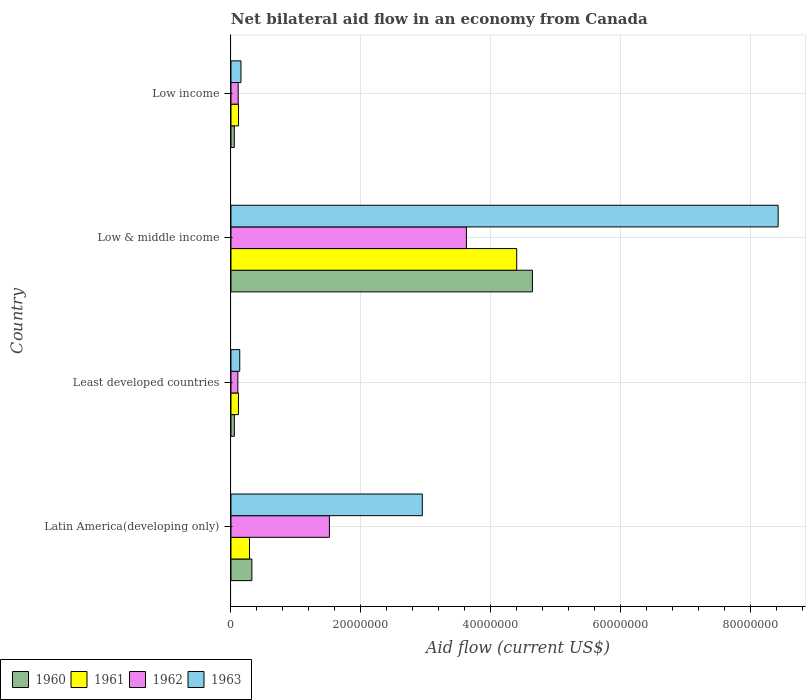How many different coloured bars are there?
Your answer should be very brief. 4. How many groups of bars are there?
Provide a succinct answer. 4. How many bars are there on the 1st tick from the top?
Give a very brief answer. 4. What is the label of the 2nd group of bars from the top?
Offer a terse response. Low & middle income. In how many cases, is the number of bars for a given country not equal to the number of legend labels?
Offer a terse response. 0. What is the net bilateral aid flow in 1962 in Latin America(developing only)?
Provide a succinct answer. 1.52e+07. Across all countries, what is the maximum net bilateral aid flow in 1963?
Give a very brief answer. 8.42e+07. Across all countries, what is the minimum net bilateral aid flow in 1962?
Offer a terse response. 1.06e+06. What is the total net bilateral aid flow in 1961 in the graph?
Offer a very short reply. 4.91e+07. What is the difference between the net bilateral aid flow in 1961 in Low & middle income and that in Low income?
Your response must be concise. 4.28e+07. What is the difference between the net bilateral aid flow in 1960 in Latin America(developing only) and the net bilateral aid flow in 1961 in Least developed countries?
Your answer should be compact. 2.07e+06. What is the average net bilateral aid flow in 1963 per country?
Provide a short and direct response. 2.91e+07. What is the difference between the net bilateral aid flow in 1960 and net bilateral aid flow in 1961 in Low & middle income?
Make the answer very short. 2.42e+06. What is the ratio of the net bilateral aid flow in 1960 in Least developed countries to that in Low & middle income?
Ensure brevity in your answer.  0.01. Is the difference between the net bilateral aid flow in 1960 in Latin America(developing only) and Low income greater than the difference between the net bilateral aid flow in 1961 in Latin America(developing only) and Low income?
Make the answer very short. Yes. What is the difference between the highest and the second highest net bilateral aid flow in 1961?
Give a very brief answer. 4.11e+07. What is the difference between the highest and the lowest net bilateral aid flow in 1960?
Keep it short and to the point. 4.59e+07. In how many countries, is the net bilateral aid flow in 1962 greater than the average net bilateral aid flow in 1962 taken over all countries?
Provide a succinct answer. 2. Is the sum of the net bilateral aid flow in 1962 in Least developed countries and Low income greater than the maximum net bilateral aid flow in 1961 across all countries?
Provide a short and direct response. No. Is it the case that in every country, the sum of the net bilateral aid flow in 1961 and net bilateral aid flow in 1963 is greater than the sum of net bilateral aid flow in 1962 and net bilateral aid flow in 1960?
Offer a terse response. No. What does the 2nd bar from the top in Latin America(developing only) represents?
Provide a short and direct response. 1962. Does the graph contain any zero values?
Keep it short and to the point. No. How are the legend labels stacked?
Make the answer very short. Horizontal. What is the title of the graph?
Provide a succinct answer. Net bilateral aid flow in an economy from Canada. Does "1998" appear as one of the legend labels in the graph?
Keep it short and to the point. No. What is the Aid flow (current US$) of 1960 in Latin America(developing only)?
Provide a succinct answer. 3.22e+06. What is the Aid flow (current US$) in 1961 in Latin America(developing only)?
Provide a short and direct response. 2.85e+06. What is the Aid flow (current US$) in 1962 in Latin America(developing only)?
Provide a short and direct response. 1.52e+07. What is the Aid flow (current US$) of 1963 in Latin America(developing only)?
Provide a succinct answer. 2.94e+07. What is the Aid flow (current US$) of 1960 in Least developed countries?
Your response must be concise. 5.20e+05. What is the Aid flow (current US$) of 1961 in Least developed countries?
Provide a succinct answer. 1.15e+06. What is the Aid flow (current US$) in 1962 in Least developed countries?
Provide a short and direct response. 1.06e+06. What is the Aid flow (current US$) in 1963 in Least developed countries?
Make the answer very short. 1.35e+06. What is the Aid flow (current US$) in 1960 in Low & middle income?
Offer a terse response. 4.64e+07. What is the Aid flow (current US$) of 1961 in Low & middle income?
Provide a short and direct response. 4.40e+07. What is the Aid flow (current US$) in 1962 in Low & middle income?
Your answer should be very brief. 3.62e+07. What is the Aid flow (current US$) in 1963 in Low & middle income?
Your answer should be very brief. 8.42e+07. What is the Aid flow (current US$) in 1960 in Low income?
Your response must be concise. 5.10e+05. What is the Aid flow (current US$) in 1961 in Low income?
Offer a terse response. 1.16e+06. What is the Aid flow (current US$) of 1962 in Low income?
Your response must be concise. 1.11e+06. What is the Aid flow (current US$) of 1963 in Low income?
Provide a succinct answer. 1.54e+06. Across all countries, what is the maximum Aid flow (current US$) of 1960?
Provide a succinct answer. 4.64e+07. Across all countries, what is the maximum Aid flow (current US$) in 1961?
Your response must be concise. 4.40e+07. Across all countries, what is the maximum Aid flow (current US$) of 1962?
Your answer should be very brief. 3.62e+07. Across all countries, what is the maximum Aid flow (current US$) of 1963?
Offer a very short reply. 8.42e+07. Across all countries, what is the minimum Aid flow (current US$) of 1960?
Offer a very short reply. 5.10e+05. Across all countries, what is the minimum Aid flow (current US$) in 1961?
Your answer should be very brief. 1.15e+06. Across all countries, what is the minimum Aid flow (current US$) of 1962?
Offer a terse response. 1.06e+06. Across all countries, what is the minimum Aid flow (current US$) in 1963?
Your response must be concise. 1.35e+06. What is the total Aid flow (current US$) in 1960 in the graph?
Make the answer very short. 5.06e+07. What is the total Aid flow (current US$) in 1961 in the graph?
Offer a very short reply. 4.91e+07. What is the total Aid flow (current US$) of 1962 in the graph?
Provide a succinct answer. 5.36e+07. What is the total Aid flow (current US$) of 1963 in the graph?
Give a very brief answer. 1.17e+08. What is the difference between the Aid flow (current US$) of 1960 in Latin America(developing only) and that in Least developed countries?
Keep it short and to the point. 2.70e+06. What is the difference between the Aid flow (current US$) of 1961 in Latin America(developing only) and that in Least developed countries?
Ensure brevity in your answer.  1.70e+06. What is the difference between the Aid flow (current US$) of 1962 in Latin America(developing only) and that in Least developed countries?
Your response must be concise. 1.41e+07. What is the difference between the Aid flow (current US$) in 1963 in Latin America(developing only) and that in Least developed countries?
Keep it short and to the point. 2.81e+07. What is the difference between the Aid flow (current US$) in 1960 in Latin America(developing only) and that in Low & middle income?
Your answer should be compact. -4.32e+07. What is the difference between the Aid flow (current US$) of 1961 in Latin America(developing only) and that in Low & middle income?
Offer a very short reply. -4.11e+07. What is the difference between the Aid flow (current US$) in 1962 in Latin America(developing only) and that in Low & middle income?
Your answer should be compact. -2.11e+07. What is the difference between the Aid flow (current US$) of 1963 in Latin America(developing only) and that in Low & middle income?
Provide a short and direct response. -5.48e+07. What is the difference between the Aid flow (current US$) of 1960 in Latin America(developing only) and that in Low income?
Your answer should be compact. 2.71e+06. What is the difference between the Aid flow (current US$) of 1961 in Latin America(developing only) and that in Low income?
Offer a very short reply. 1.69e+06. What is the difference between the Aid flow (current US$) of 1962 in Latin America(developing only) and that in Low income?
Your answer should be compact. 1.40e+07. What is the difference between the Aid flow (current US$) of 1963 in Latin America(developing only) and that in Low income?
Give a very brief answer. 2.79e+07. What is the difference between the Aid flow (current US$) of 1960 in Least developed countries and that in Low & middle income?
Provide a succinct answer. -4.59e+07. What is the difference between the Aid flow (current US$) of 1961 in Least developed countries and that in Low & middle income?
Provide a short and direct response. -4.28e+07. What is the difference between the Aid flow (current US$) in 1962 in Least developed countries and that in Low & middle income?
Provide a succinct answer. -3.52e+07. What is the difference between the Aid flow (current US$) in 1963 in Least developed countries and that in Low & middle income?
Ensure brevity in your answer.  -8.29e+07. What is the difference between the Aid flow (current US$) of 1961 in Least developed countries and that in Low income?
Give a very brief answer. -10000. What is the difference between the Aid flow (current US$) of 1962 in Least developed countries and that in Low income?
Make the answer very short. -5.00e+04. What is the difference between the Aid flow (current US$) of 1963 in Least developed countries and that in Low income?
Your response must be concise. -1.90e+05. What is the difference between the Aid flow (current US$) of 1960 in Low & middle income and that in Low income?
Your response must be concise. 4.59e+07. What is the difference between the Aid flow (current US$) in 1961 in Low & middle income and that in Low income?
Ensure brevity in your answer.  4.28e+07. What is the difference between the Aid flow (current US$) in 1962 in Low & middle income and that in Low income?
Provide a succinct answer. 3.51e+07. What is the difference between the Aid flow (current US$) of 1963 in Low & middle income and that in Low income?
Provide a short and direct response. 8.27e+07. What is the difference between the Aid flow (current US$) in 1960 in Latin America(developing only) and the Aid flow (current US$) in 1961 in Least developed countries?
Offer a terse response. 2.07e+06. What is the difference between the Aid flow (current US$) in 1960 in Latin America(developing only) and the Aid flow (current US$) in 1962 in Least developed countries?
Offer a terse response. 2.16e+06. What is the difference between the Aid flow (current US$) of 1960 in Latin America(developing only) and the Aid flow (current US$) of 1963 in Least developed countries?
Your answer should be compact. 1.87e+06. What is the difference between the Aid flow (current US$) in 1961 in Latin America(developing only) and the Aid flow (current US$) in 1962 in Least developed countries?
Keep it short and to the point. 1.79e+06. What is the difference between the Aid flow (current US$) in 1961 in Latin America(developing only) and the Aid flow (current US$) in 1963 in Least developed countries?
Make the answer very short. 1.50e+06. What is the difference between the Aid flow (current US$) of 1962 in Latin America(developing only) and the Aid flow (current US$) of 1963 in Least developed countries?
Your answer should be compact. 1.38e+07. What is the difference between the Aid flow (current US$) of 1960 in Latin America(developing only) and the Aid flow (current US$) of 1961 in Low & middle income?
Provide a short and direct response. -4.08e+07. What is the difference between the Aid flow (current US$) in 1960 in Latin America(developing only) and the Aid flow (current US$) in 1962 in Low & middle income?
Ensure brevity in your answer.  -3.30e+07. What is the difference between the Aid flow (current US$) of 1960 in Latin America(developing only) and the Aid flow (current US$) of 1963 in Low & middle income?
Your response must be concise. -8.10e+07. What is the difference between the Aid flow (current US$) of 1961 in Latin America(developing only) and the Aid flow (current US$) of 1962 in Low & middle income?
Your answer should be compact. -3.34e+07. What is the difference between the Aid flow (current US$) in 1961 in Latin America(developing only) and the Aid flow (current US$) in 1963 in Low & middle income?
Provide a succinct answer. -8.14e+07. What is the difference between the Aid flow (current US$) in 1962 in Latin America(developing only) and the Aid flow (current US$) in 1963 in Low & middle income?
Give a very brief answer. -6.91e+07. What is the difference between the Aid flow (current US$) in 1960 in Latin America(developing only) and the Aid flow (current US$) in 1961 in Low income?
Offer a very short reply. 2.06e+06. What is the difference between the Aid flow (current US$) in 1960 in Latin America(developing only) and the Aid flow (current US$) in 1962 in Low income?
Ensure brevity in your answer.  2.11e+06. What is the difference between the Aid flow (current US$) in 1960 in Latin America(developing only) and the Aid flow (current US$) in 1963 in Low income?
Keep it short and to the point. 1.68e+06. What is the difference between the Aid flow (current US$) in 1961 in Latin America(developing only) and the Aid flow (current US$) in 1962 in Low income?
Give a very brief answer. 1.74e+06. What is the difference between the Aid flow (current US$) in 1961 in Latin America(developing only) and the Aid flow (current US$) in 1963 in Low income?
Your answer should be very brief. 1.31e+06. What is the difference between the Aid flow (current US$) of 1962 in Latin America(developing only) and the Aid flow (current US$) of 1963 in Low income?
Keep it short and to the point. 1.36e+07. What is the difference between the Aid flow (current US$) in 1960 in Least developed countries and the Aid flow (current US$) in 1961 in Low & middle income?
Your answer should be compact. -4.35e+07. What is the difference between the Aid flow (current US$) of 1960 in Least developed countries and the Aid flow (current US$) of 1962 in Low & middle income?
Your response must be concise. -3.57e+07. What is the difference between the Aid flow (current US$) of 1960 in Least developed countries and the Aid flow (current US$) of 1963 in Low & middle income?
Give a very brief answer. -8.37e+07. What is the difference between the Aid flow (current US$) of 1961 in Least developed countries and the Aid flow (current US$) of 1962 in Low & middle income?
Your response must be concise. -3.51e+07. What is the difference between the Aid flow (current US$) in 1961 in Least developed countries and the Aid flow (current US$) in 1963 in Low & middle income?
Keep it short and to the point. -8.31e+07. What is the difference between the Aid flow (current US$) in 1962 in Least developed countries and the Aid flow (current US$) in 1963 in Low & middle income?
Provide a succinct answer. -8.32e+07. What is the difference between the Aid flow (current US$) of 1960 in Least developed countries and the Aid flow (current US$) of 1961 in Low income?
Keep it short and to the point. -6.40e+05. What is the difference between the Aid flow (current US$) in 1960 in Least developed countries and the Aid flow (current US$) in 1962 in Low income?
Your response must be concise. -5.90e+05. What is the difference between the Aid flow (current US$) of 1960 in Least developed countries and the Aid flow (current US$) of 1963 in Low income?
Make the answer very short. -1.02e+06. What is the difference between the Aid flow (current US$) in 1961 in Least developed countries and the Aid flow (current US$) in 1962 in Low income?
Provide a short and direct response. 4.00e+04. What is the difference between the Aid flow (current US$) of 1961 in Least developed countries and the Aid flow (current US$) of 1963 in Low income?
Offer a terse response. -3.90e+05. What is the difference between the Aid flow (current US$) in 1962 in Least developed countries and the Aid flow (current US$) in 1963 in Low income?
Provide a succinct answer. -4.80e+05. What is the difference between the Aid flow (current US$) in 1960 in Low & middle income and the Aid flow (current US$) in 1961 in Low income?
Offer a terse response. 4.52e+07. What is the difference between the Aid flow (current US$) of 1960 in Low & middle income and the Aid flow (current US$) of 1962 in Low income?
Keep it short and to the point. 4.53e+07. What is the difference between the Aid flow (current US$) in 1960 in Low & middle income and the Aid flow (current US$) in 1963 in Low income?
Provide a succinct answer. 4.49e+07. What is the difference between the Aid flow (current US$) in 1961 in Low & middle income and the Aid flow (current US$) in 1962 in Low income?
Keep it short and to the point. 4.29e+07. What is the difference between the Aid flow (current US$) of 1961 in Low & middle income and the Aid flow (current US$) of 1963 in Low income?
Make the answer very short. 4.24e+07. What is the difference between the Aid flow (current US$) of 1962 in Low & middle income and the Aid flow (current US$) of 1963 in Low income?
Make the answer very short. 3.47e+07. What is the average Aid flow (current US$) of 1960 per country?
Your answer should be compact. 1.27e+07. What is the average Aid flow (current US$) of 1961 per country?
Keep it short and to the point. 1.23e+07. What is the average Aid flow (current US$) of 1962 per country?
Provide a short and direct response. 1.34e+07. What is the average Aid flow (current US$) of 1963 per country?
Your answer should be compact. 2.91e+07. What is the difference between the Aid flow (current US$) in 1960 and Aid flow (current US$) in 1962 in Latin America(developing only)?
Keep it short and to the point. -1.19e+07. What is the difference between the Aid flow (current US$) in 1960 and Aid flow (current US$) in 1963 in Latin America(developing only)?
Your answer should be compact. -2.62e+07. What is the difference between the Aid flow (current US$) in 1961 and Aid flow (current US$) in 1962 in Latin America(developing only)?
Make the answer very short. -1.23e+07. What is the difference between the Aid flow (current US$) in 1961 and Aid flow (current US$) in 1963 in Latin America(developing only)?
Keep it short and to the point. -2.66e+07. What is the difference between the Aid flow (current US$) in 1962 and Aid flow (current US$) in 1963 in Latin America(developing only)?
Offer a terse response. -1.43e+07. What is the difference between the Aid flow (current US$) in 1960 and Aid flow (current US$) in 1961 in Least developed countries?
Your answer should be very brief. -6.30e+05. What is the difference between the Aid flow (current US$) in 1960 and Aid flow (current US$) in 1962 in Least developed countries?
Your answer should be compact. -5.40e+05. What is the difference between the Aid flow (current US$) of 1960 and Aid flow (current US$) of 1963 in Least developed countries?
Give a very brief answer. -8.30e+05. What is the difference between the Aid flow (current US$) of 1962 and Aid flow (current US$) of 1963 in Least developed countries?
Provide a short and direct response. -2.90e+05. What is the difference between the Aid flow (current US$) in 1960 and Aid flow (current US$) in 1961 in Low & middle income?
Ensure brevity in your answer.  2.42e+06. What is the difference between the Aid flow (current US$) in 1960 and Aid flow (current US$) in 1962 in Low & middle income?
Your answer should be very brief. 1.02e+07. What is the difference between the Aid flow (current US$) in 1960 and Aid flow (current US$) in 1963 in Low & middle income?
Your response must be concise. -3.78e+07. What is the difference between the Aid flow (current US$) of 1961 and Aid flow (current US$) of 1962 in Low & middle income?
Provide a succinct answer. 7.74e+06. What is the difference between the Aid flow (current US$) in 1961 and Aid flow (current US$) in 1963 in Low & middle income?
Provide a succinct answer. -4.02e+07. What is the difference between the Aid flow (current US$) of 1962 and Aid flow (current US$) of 1963 in Low & middle income?
Your answer should be compact. -4.80e+07. What is the difference between the Aid flow (current US$) of 1960 and Aid flow (current US$) of 1961 in Low income?
Your answer should be compact. -6.50e+05. What is the difference between the Aid flow (current US$) in 1960 and Aid flow (current US$) in 1962 in Low income?
Your response must be concise. -6.00e+05. What is the difference between the Aid flow (current US$) of 1960 and Aid flow (current US$) of 1963 in Low income?
Offer a terse response. -1.03e+06. What is the difference between the Aid flow (current US$) of 1961 and Aid flow (current US$) of 1962 in Low income?
Provide a short and direct response. 5.00e+04. What is the difference between the Aid flow (current US$) of 1961 and Aid flow (current US$) of 1963 in Low income?
Provide a short and direct response. -3.80e+05. What is the difference between the Aid flow (current US$) of 1962 and Aid flow (current US$) of 1963 in Low income?
Offer a terse response. -4.30e+05. What is the ratio of the Aid flow (current US$) in 1960 in Latin America(developing only) to that in Least developed countries?
Provide a short and direct response. 6.19. What is the ratio of the Aid flow (current US$) in 1961 in Latin America(developing only) to that in Least developed countries?
Provide a succinct answer. 2.48. What is the ratio of the Aid flow (current US$) in 1962 in Latin America(developing only) to that in Least developed countries?
Make the answer very short. 14.29. What is the ratio of the Aid flow (current US$) in 1963 in Latin America(developing only) to that in Least developed countries?
Offer a terse response. 21.81. What is the ratio of the Aid flow (current US$) in 1960 in Latin America(developing only) to that in Low & middle income?
Make the answer very short. 0.07. What is the ratio of the Aid flow (current US$) of 1961 in Latin America(developing only) to that in Low & middle income?
Give a very brief answer. 0.06. What is the ratio of the Aid flow (current US$) in 1962 in Latin America(developing only) to that in Low & middle income?
Provide a short and direct response. 0.42. What is the ratio of the Aid flow (current US$) of 1963 in Latin America(developing only) to that in Low & middle income?
Provide a short and direct response. 0.35. What is the ratio of the Aid flow (current US$) in 1960 in Latin America(developing only) to that in Low income?
Provide a short and direct response. 6.31. What is the ratio of the Aid flow (current US$) of 1961 in Latin America(developing only) to that in Low income?
Your answer should be compact. 2.46. What is the ratio of the Aid flow (current US$) of 1962 in Latin America(developing only) to that in Low income?
Keep it short and to the point. 13.65. What is the ratio of the Aid flow (current US$) in 1963 in Latin America(developing only) to that in Low income?
Make the answer very short. 19.12. What is the ratio of the Aid flow (current US$) of 1960 in Least developed countries to that in Low & middle income?
Provide a succinct answer. 0.01. What is the ratio of the Aid flow (current US$) in 1961 in Least developed countries to that in Low & middle income?
Provide a succinct answer. 0.03. What is the ratio of the Aid flow (current US$) in 1962 in Least developed countries to that in Low & middle income?
Keep it short and to the point. 0.03. What is the ratio of the Aid flow (current US$) of 1963 in Least developed countries to that in Low & middle income?
Offer a terse response. 0.02. What is the ratio of the Aid flow (current US$) of 1960 in Least developed countries to that in Low income?
Your answer should be very brief. 1.02. What is the ratio of the Aid flow (current US$) of 1961 in Least developed countries to that in Low income?
Your response must be concise. 0.99. What is the ratio of the Aid flow (current US$) in 1962 in Least developed countries to that in Low income?
Offer a terse response. 0.95. What is the ratio of the Aid flow (current US$) in 1963 in Least developed countries to that in Low income?
Provide a short and direct response. 0.88. What is the ratio of the Aid flow (current US$) in 1960 in Low & middle income to that in Low income?
Provide a short and direct response. 90.98. What is the ratio of the Aid flow (current US$) in 1961 in Low & middle income to that in Low income?
Provide a short and direct response. 37.91. What is the ratio of the Aid flow (current US$) of 1962 in Low & middle income to that in Low income?
Give a very brief answer. 32.65. What is the ratio of the Aid flow (current US$) of 1963 in Low & middle income to that in Low income?
Offer a terse response. 54.69. What is the difference between the highest and the second highest Aid flow (current US$) in 1960?
Your answer should be compact. 4.32e+07. What is the difference between the highest and the second highest Aid flow (current US$) of 1961?
Your answer should be very brief. 4.11e+07. What is the difference between the highest and the second highest Aid flow (current US$) of 1962?
Keep it short and to the point. 2.11e+07. What is the difference between the highest and the second highest Aid flow (current US$) in 1963?
Your answer should be very brief. 5.48e+07. What is the difference between the highest and the lowest Aid flow (current US$) of 1960?
Offer a terse response. 4.59e+07. What is the difference between the highest and the lowest Aid flow (current US$) in 1961?
Your answer should be very brief. 4.28e+07. What is the difference between the highest and the lowest Aid flow (current US$) in 1962?
Make the answer very short. 3.52e+07. What is the difference between the highest and the lowest Aid flow (current US$) in 1963?
Offer a terse response. 8.29e+07. 